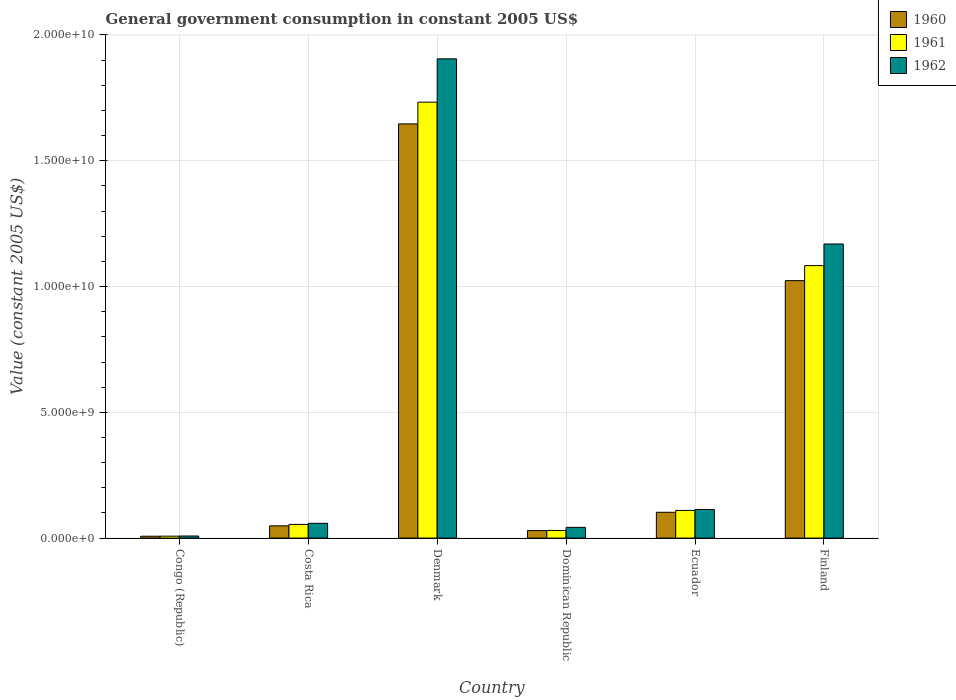How many groups of bars are there?
Your response must be concise. 6. Are the number of bars on each tick of the X-axis equal?
Offer a very short reply. Yes. How many bars are there on the 3rd tick from the right?
Make the answer very short. 3. What is the label of the 2nd group of bars from the left?
Your answer should be very brief. Costa Rica. In how many cases, is the number of bars for a given country not equal to the number of legend labels?
Make the answer very short. 0. What is the government conusmption in 1961 in Finland?
Provide a succinct answer. 1.08e+1. Across all countries, what is the maximum government conusmption in 1962?
Keep it short and to the point. 1.91e+1. Across all countries, what is the minimum government conusmption in 1962?
Your answer should be compact. 8.33e+07. In which country was the government conusmption in 1962 maximum?
Provide a short and direct response. Denmark. In which country was the government conusmption in 1961 minimum?
Provide a short and direct response. Congo (Republic). What is the total government conusmption in 1962 in the graph?
Offer a very short reply. 3.30e+1. What is the difference between the government conusmption in 1962 in Costa Rica and that in Finland?
Your answer should be compact. -1.11e+1. What is the difference between the government conusmption in 1960 in Ecuador and the government conusmption in 1961 in Dominican Republic?
Make the answer very short. 7.22e+08. What is the average government conusmption in 1960 per country?
Your answer should be compact. 4.76e+09. What is the difference between the government conusmption of/in 1962 and government conusmption of/in 1961 in Costa Rica?
Your response must be concise. 4.32e+07. What is the ratio of the government conusmption in 1962 in Congo (Republic) to that in Costa Rica?
Your response must be concise. 0.14. Is the government conusmption in 1961 in Costa Rica less than that in Dominican Republic?
Your response must be concise. No. Is the difference between the government conusmption in 1962 in Ecuador and Finland greater than the difference between the government conusmption in 1961 in Ecuador and Finland?
Keep it short and to the point. No. What is the difference between the highest and the second highest government conusmption in 1962?
Offer a very short reply. 1.06e+1. What is the difference between the highest and the lowest government conusmption in 1961?
Ensure brevity in your answer.  1.73e+1. In how many countries, is the government conusmption in 1961 greater than the average government conusmption in 1961 taken over all countries?
Your answer should be compact. 2. What does the 2nd bar from the left in Denmark represents?
Your answer should be very brief. 1961. What is the difference between two consecutive major ticks on the Y-axis?
Give a very brief answer. 5.00e+09. Are the values on the major ticks of Y-axis written in scientific E-notation?
Offer a very short reply. Yes. Does the graph contain grids?
Provide a succinct answer. Yes. Where does the legend appear in the graph?
Your answer should be compact. Top right. How are the legend labels stacked?
Provide a short and direct response. Vertical. What is the title of the graph?
Keep it short and to the point. General government consumption in constant 2005 US$. Does "1973" appear as one of the legend labels in the graph?
Your answer should be very brief. No. What is the label or title of the X-axis?
Your answer should be very brief. Country. What is the label or title of the Y-axis?
Your response must be concise. Value (constant 2005 US$). What is the Value (constant 2005 US$) in 1960 in Congo (Republic)?
Offer a terse response. 7.44e+07. What is the Value (constant 2005 US$) of 1961 in Congo (Republic)?
Your answer should be compact. 7.67e+07. What is the Value (constant 2005 US$) of 1962 in Congo (Republic)?
Offer a terse response. 8.33e+07. What is the Value (constant 2005 US$) in 1960 in Costa Rica?
Keep it short and to the point. 4.87e+08. What is the Value (constant 2005 US$) of 1961 in Costa Rica?
Provide a short and direct response. 5.45e+08. What is the Value (constant 2005 US$) of 1962 in Costa Rica?
Ensure brevity in your answer.  5.88e+08. What is the Value (constant 2005 US$) of 1960 in Denmark?
Offer a very short reply. 1.65e+1. What is the Value (constant 2005 US$) of 1961 in Denmark?
Your response must be concise. 1.73e+1. What is the Value (constant 2005 US$) in 1962 in Denmark?
Make the answer very short. 1.91e+1. What is the Value (constant 2005 US$) of 1960 in Dominican Republic?
Make the answer very short. 2.99e+08. What is the Value (constant 2005 US$) in 1961 in Dominican Republic?
Your answer should be compact. 3.03e+08. What is the Value (constant 2005 US$) of 1962 in Dominican Republic?
Your answer should be very brief. 4.27e+08. What is the Value (constant 2005 US$) in 1960 in Ecuador?
Ensure brevity in your answer.  1.03e+09. What is the Value (constant 2005 US$) of 1961 in Ecuador?
Provide a succinct answer. 1.10e+09. What is the Value (constant 2005 US$) of 1962 in Ecuador?
Offer a very short reply. 1.14e+09. What is the Value (constant 2005 US$) in 1960 in Finland?
Your answer should be compact. 1.02e+1. What is the Value (constant 2005 US$) of 1961 in Finland?
Offer a terse response. 1.08e+1. What is the Value (constant 2005 US$) in 1962 in Finland?
Keep it short and to the point. 1.17e+1. Across all countries, what is the maximum Value (constant 2005 US$) in 1960?
Make the answer very short. 1.65e+1. Across all countries, what is the maximum Value (constant 2005 US$) in 1961?
Make the answer very short. 1.73e+1. Across all countries, what is the maximum Value (constant 2005 US$) of 1962?
Offer a very short reply. 1.91e+1. Across all countries, what is the minimum Value (constant 2005 US$) in 1960?
Your answer should be very brief. 7.44e+07. Across all countries, what is the minimum Value (constant 2005 US$) in 1961?
Ensure brevity in your answer.  7.67e+07. Across all countries, what is the minimum Value (constant 2005 US$) in 1962?
Provide a short and direct response. 8.33e+07. What is the total Value (constant 2005 US$) in 1960 in the graph?
Provide a succinct answer. 2.86e+1. What is the total Value (constant 2005 US$) in 1961 in the graph?
Your answer should be compact. 3.02e+1. What is the total Value (constant 2005 US$) of 1962 in the graph?
Offer a terse response. 3.30e+1. What is the difference between the Value (constant 2005 US$) of 1960 in Congo (Republic) and that in Costa Rica?
Ensure brevity in your answer.  -4.12e+08. What is the difference between the Value (constant 2005 US$) in 1961 in Congo (Republic) and that in Costa Rica?
Provide a succinct answer. -4.68e+08. What is the difference between the Value (constant 2005 US$) of 1962 in Congo (Republic) and that in Costa Rica?
Your answer should be compact. -5.05e+08. What is the difference between the Value (constant 2005 US$) of 1960 in Congo (Republic) and that in Denmark?
Ensure brevity in your answer.  -1.64e+1. What is the difference between the Value (constant 2005 US$) of 1961 in Congo (Republic) and that in Denmark?
Make the answer very short. -1.73e+1. What is the difference between the Value (constant 2005 US$) in 1962 in Congo (Republic) and that in Denmark?
Keep it short and to the point. -1.90e+1. What is the difference between the Value (constant 2005 US$) in 1960 in Congo (Republic) and that in Dominican Republic?
Offer a very short reply. -2.24e+08. What is the difference between the Value (constant 2005 US$) of 1961 in Congo (Republic) and that in Dominican Republic?
Your answer should be compact. -2.27e+08. What is the difference between the Value (constant 2005 US$) of 1962 in Congo (Republic) and that in Dominican Republic?
Your response must be concise. -3.43e+08. What is the difference between the Value (constant 2005 US$) in 1960 in Congo (Republic) and that in Ecuador?
Ensure brevity in your answer.  -9.51e+08. What is the difference between the Value (constant 2005 US$) in 1961 in Congo (Republic) and that in Ecuador?
Make the answer very short. -1.02e+09. What is the difference between the Value (constant 2005 US$) in 1962 in Congo (Republic) and that in Ecuador?
Make the answer very short. -1.05e+09. What is the difference between the Value (constant 2005 US$) in 1960 in Congo (Republic) and that in Finland?
Give a very brief answer. -1.02e+1. What is the difference between the Value (constant 2005 US$) of 1961 in Congo (Republic) and that in Finland?
Give a very brief answer. -1.08e+1. What is the difference between the Value (constant 2005 US$) in 1962 in Congo (Republic) and that in Finland?
Provide a succinct answer. -1.16e+1. What is the difference between the Value (constant 2005 US$) of 1960 in Costa Rica and that in Denmark?
Make the answer very short. -1.60e+1. What is the difference between the Value (constant 2005 US$) of 1961 in Costa Rica and that in Denmark?
Your response must be concise. -1.68e+1. What is the difference between the Value (constant 2005 US$) in 1962 in Costa Rica and that in Denmark?
Offer a terse response. -1.85e+1. What is the difference between the Value (constant 2005 US$) in 1960 in Costa Rica and that in Dominican Republic?
Ensure brevity in your answer.  1.88e+08. What is the difference between the Value (constant 2005 US$) of 1961 in Costa Rica and that in Dominican Republic?
Your answer should be compact. 2.41e+08. What is the difference between the Value (constant 2005 US$) in 1962 in Costa Rica and that in Dominican Republic?
Offer a very short reply. 1.61e+08. What is the difference between the Value (constant 2005 US$) of 1960 in Costa Rica and that in Ecuador?
Ensure brevity in your answer.  -5.39e+08. What is the difference between the Value (constant 2005 US$) in 1961 in Costa Rica and that in Ecuador?
Offer a very short reply. -5.55e+08. What is the difference between the Value (constant 2005 US$) of 1962 in Costa Rica and that in Ecuador?
Your answer should be very brief. -5.50e+08. What is the difference between the Value (constant 2005 US$) in 1960 in Costa Rica and that in Finland?
Your answer should be compact. -9.75e+09. What is the difference between the Value (constant 2005 US$) of 1961 in Costa Rica and that in Finland?
Make the answer very short. -1.03e+1. What is the difference between the Value (constant 2005 US$) in 1962 in Costa Rica and that in Finland?
Your response must be concise. -1.11e+1. What is the difference between the Value (constant 2005 US$) of 1960 in Denmark and that in Dominican Republic?
Offer a terse response. 1.62e+1. What is the difference between the Value (constant 2005 US$) in 1961 in Denmark and that in Dominican Republic?
Offer a very short reply. 1.70e+1. What is the difference between the Value (constant 2005 US$) of 1962 in Denmark and that in Dominican Republic?
Make the answer very short. 1.86e+1. What is the difference between the Value (constant 2005 US$) of 1960 in Denmark and that in Ecuador?
Offer a very short reply. 1.54e+1. What is the difference between the Value (constant 2005 US$) of 1961 in Denmark and that in Ecuador?
Keep it short and to the point. 1.62e+1. What is the difference between the Value (constant 2005 US$) in 1962 in Denmark and that in Ecuador?
Keep it short and to the point. 1.79e+1. What is the difference between the Value (constant 2005 US$) of 1960 in Denmark and that in Finland?
Offer a very short reply. 6.23e+09. What is the difference between the Value (constant 2005 US$) in 1961 in Denmark and that in Finland?
Ensure brevity in your answer.  6.50e+09. What is the difference between the Value (constant 2005 US$) in 1962 in Denmark and that in Finland?
Your response must be concise. 7.36e+09. What is the difference between the Value (constant 2005 US$) in 1960 in Dominican Republic and that in Ecuador?
Provide a succinct answer. -7.27e+08. What is the difference between the Value (constant 2005 US$) in 1961 in Dominican Republic and that in Ecuador?
Offer a terse response. -7.96e+08. What is the difference between the Value (constant 2005 US$) of 1962 in Dominican Republic and that in Ecuador?
Offer a very short reply. -7.11e+08. What is the difference between the Value (constant 2005 US$) in 1960 in Dominican Republic and that in Finland?
Make the answer very short. -9.94e+09. What is the difference between the Value (constant 2005 US$) in 1961 in Dominican Republic and that in Finland?
Your answer should be compact. -1.05e+1. What is the difference between the Value (constant 2005 US$) of 1962 in Dominican Republic and that in Finland?
Your response must be concise. -1.13e+1. What is the difference between the Value (constant 2005 US$) of 1960 in Ecuador and that in Finland?
Give a very brief answer. -9.21e+09. What is the difference between the Value (constant 2005 US$) of 1961 in Ecuador and that in Finland?
Offer a very short reply. -9.73e+09. What is the difference between the Value (constant 2005 US$) in 1962 in Ecuador and that in Finland?
Provide a short and direct response. -1.06e+1. What is the difference between the Value (constant 2005 US$) of 1960 in Congo (Republic) and the Value (constant 2005 US$) of 1961 in Costa Rica?
Offer a terse response. -4.70e+08. What is the difference between the Value (constant 2005 US$) of 1960 in Congo (Republic) and the Value (constant 2005 US$) of 1962 in Costa Rica?
Your response must be concise. -5.13e+08. What is the difference between the Value (constant 2005 US$) in 1961 in Congo (Republic) and the Value (constant 2005 US$) in 1962 in Costa Rica?
Give a very brief answer. -5.11e+08. What is the difference between the Value (constant 2005 US$) of 1960 in Congo (Republic) and the Value (constant 2005 US$) of 1961 in Denmark?
Offer a very short reply. -1.73e+1. What is the difference between the Value (constant 2005 US$) of 1960 in Congo (Republic) and the Value (constant 2005 US$) of 1962 in Denmark?
Offer a terse response. -1.90e+1. What is the difference between the Value (constant 2005 US$) of 1961 in Congo (Republic) and the Value (constant 2005 US$) of 1962 in Denmark?
Your response must be concise. -1.90e+1. What is the difference between the Value (constant 2005 US$) in 1960 in Congo (Republic) and the Value (constant 2005 US$) in 1961 in Dominican Republic?
Keep it short and to the point. -2.29e+08. What is the difference between the Value (constant 2005 US$) of 1960 in Congo (Republic) and the Value (constant 2005 US$) of 1962 in Dominican Republic?
Your response must be concise. -3.52e+08. What is the difference between the Value (constant 2005 US$) of 1961 in Congo (Republic) and the Value (constant 2005 US$) of 1962 in Dominican Republic?
Offer a terse response. -3.50e+08. What is the difference between the Value (constant 2005 US$) in 1960 in Congo (Republic) and the Value (constant 2005 US$) in 1961 in Ecuador?
Provide a short and direct response. -1.02e+09. What is the difference between the Value (constant 2005 US$) in 1960 in Congo (Republic) and the Value (constant 2005 US$) in 1962 in Ecuador?
Your response must be concise. -1.06e+09. What is the difference between the Value (constant 2005 US$) in 1961 in Congo (Republic) and the Value (constant 2005 US$) in 1962 in Ecuador?
Your response must be concise. -1.06e+09. What is the difference between the Value (constant 2005 US$) of 1960 in Congo (Republic) and the Value (constant 2005 US$) of 1961 in Finland?
Your answer should be compact. -1.08e+1. What is the difference between the Value (constant 2005 US$) of 1960 in Congo (Republic) and the Value (constant 2005 US$) of 1962 in Finland?
Your answer should be compact. -1.16e+1. What is the difference between the Value (constant 2005 US$) of 1961 in Congo (Republic) and the Value (constant 2005 US$) of 1962 in Finland?
Provide a succinct answer. -1.16e+1. What is the difference between the Value (constant 2005 US$) in 1960 in Costa Rica and the Value (constant 2005 US$) in 1961 in Denmark?
Ensure brevity in your answer.  -1.68e+1. What is the difference between the Value (constant 2005 US$) of 1960 in Costa Rica and the Value (constant 2005 US$) of 1962 in Denmark?
Give a very brief answer. -1.86e+1. What is the difference between the Value (constant 2005 US$) of 1961 in Costa Rica and the Value (constant 2005 US$) of 1962 in Denmark?
Provide a succinct answer. -1.85e+1. What is the difference between the Value (constant 2005 US$) of 1960 in Costa Rica and the Value (constant 2005 US$) of 1961 in Dominican Republic?
Your answer should be very brief. 1.83e+08. What is the difference between the Value (constant 2005 US$) in 1960 in Costa Rica and the Value (constant 2005 US$) in 1962 in Dominican Republic?
Your answer should be compact. 6.01e+07. What is the difference between the Value (constant 2005 US$) of 1961 in Costa Rica and the Value (constant 2005 US$) of 1962 in Dominican Republic?
Your answer should be very brief. 1.18e+08. What is the difference between the Value (constant 2005 US$) of 1960 in Costa Rica and the Value (constant 2005 US$) of 1961 in Ecuador?
Provide a short and direct response. -6.13e+08. What is the difference between the Value (constant 2005 US$) of 1960 in Costa Rica and the Value (constant 2005 US$) of 1962 in Ecuador?
Your answer should be compact. -6.51e+08. What is the difference between the Value (constant 2005 US$) in 1961 in Costa Rica and the Value (constant 2005 US$) in 1962 in Ecuador?
Your response must be concise. -5.93e+08. What is the difference between the Value (constant 2005 US$) of 1960 in Costa Rica and the Value (constant 2005 US$) of 1961 in Finland?
Provide a succinct answer. -1.03e+1. What is the difference between the Value (constant 2005 US$) of 1960 in Costa Rica and the Value (constant 2005 US$) of 1962 in Finland?
Provide a succinct answer. -1.12e+1. What is the difference between the Value (constant 2005 US$) of 1961 in Costa Rica and the Value (constant 2005 US$) of 1962 in Finland?
Provide a short and direct response. -1.11e+1. What is the difference between the Value (constant 2005 US$) in 1960 in Denmark and the Value (constant 2005 US$) in 1961 in Dominican Republic?
Provide a short and direct response. 1.62e+1. What is the difference between the Value (constant 2005 US$) in 1960 in Denmark and the Value (constant 2005 US$) in 1962 in Dominican Republic?
Ensure brevity in your answer.  1.60e+1. What is the difference between the Value (constant 2005 US$) of 1961 in Denmark and the Value (constant 2005 US$) of 1962 in Dominican Republic?
Your answer should be very brief. 1.69e+1. What is the difference between the Value (constant 2005 US$) in 1960 in Denmark and the Value (constant 2005 US$) in 1961 in Ecuador?
Your answer should be very brief. 1.54e+1. What is the difference between the Value (constant 2005 US$) of 1960 in Denmark and the Value (constant 2005 US$) of 1962 in Ecuador?
Your answer should be very brief. 1.53e+1. What is the difference between the Value (constant 2005 US$) in 1961 in Denmark and the Value (constant 2005 US$) in 1962 in Ecuador?
Give a very brief answer. 1.62e+1. What is the difference between the Value (constant 2005 US$) in 1960 in Denmark and the Value (constant 2005 US$) in 1961 in Finland?
Offer a terse response. 5.63e+09. What is the difference between the Value (constant 2005 US$) of 1960 in Denmark and the Value (constant 2005 US$) of 1962 in Finland?
Provide a succinct answer. 4.77e+09. What is the difference between the Value (constant 2005 US$) of 1961 in Denmark and the Value (constant 2005 US$) of 1962 in Finland?
Your answer should be compact. 5.64e+09. What is the difference between the Value (constant 2005 US$) of 1960 in Dominican Republic and the Value (constant 2005 US$) of 1961 in Ecuador?
Offer a terse response. -8.01e+08. What is the difference between the Value (constant 2005 US$) in 1960 in Dominican Republic and the Value (constant 2005 US$) in 1962 in Ecuador?
Offer a terse response. -8.39e+08. What is the difference between the Value (constant 2005 US$) in 1961 in Dominican Republic and the Value (constant 2005 US$) in 1962 in Ecuador?
Make the answer very short. -8.35e+08. What is the difference between the Value (constant 2005 US$) in 1960 in Dominican Republic and the Value (constant 2005 US$) in 1961 in Finland?
Provide a succinct answer. -1.05e+1. What is the difference between the Value (constant 2005 US$) in 1960 in Dominican Republic and the Value (constant 2005 US$) in 1962 in Finland?
Offer a very short reply. -1.14e+1. What is the difference between the Value (constant 2005 US$) of 1961 in Dominican Republic and the Value (constant 2005 US$) of 1962 in Finland?
Provide a succinct answer. -1.14e+1. What is the difference between the Value (constant 2005 US$) of 1960 in Ecuador and the Value (constant 2005 US$) of 1961 in Finland?
Offer a terse response. -9.81e+09. What is the difference between the Value (constant 2005 US$) of 1960 in Ecuador and the Value (constant 2005 US$) of 1962 in Finland?
Give a very brief answer. -1.07e+1. What is the difference between the Value (constant 2005 US$) in 1961 in Ecuador and the Value (constant 2005 US$) in 1962 in Finland?
Provide a succinct answer. -1.06e+1. What is the average Value (constant 2005 US$) in 1960 per country?
Your response must be concise. 4.76e+09. What is the average Value (constant 2005 US$) in 1961 per country?
Offer a very short reply. 5.03e+09. What is the average Value (constant 2005 US$) in 1962 per country?
Offer a very short reply. 5.50e+09. What is the difference between the Value (constant 2005 US$) in 1960 and Value (constant 2005 US$) in 1961 in Congo (Republic)?
Provide a succinct answer. -2.22e+06. What is the difference between the Value (constant 2005 US$) in 1960 and Value (constant 2005 US$) in 1962 in Congo (Republic)?
Your answer should be very brief. -8.89e+06. What is the difference between the Value (constant 2005 US$) of 1961 and Value (constant 2005 US$) of 1962 in Congo (Republic)?
Ensure brevity in your answer.  -6.67e+06. What is the difference between the Value (constant 2005 US$) of 1960 and Value (constant 2005 US$) of 1961 in Costa Rica?
Your answer should be very brief. -5.79e+07. What is the difference between the Value (constant 2005 US$) in 1960 and Value (constant 2005 US$) in 1962 in Costa Rica?
Provide a succinct answer. -1.01e+08. What is the difference between the Value (constant 2005 US$) in 1961 and Value (constant 2005 US$) in 1962 in Costa Rica?
Provide a short and direct response. -4.32e+07. What is the difference between the Value (constant 2005 US$) in 1960 and Value (constant 2005 US$) in 1961 in Denmark?
Ensure brevity in your answer.  -8.65e+08. What is the difference between the Value (constant 2005 US$) of 1960 and Value (constant 2005 US$) of 1962 in Denmark?
Your answer should be compact. -2.59e+09. What is the difference between the Value (constant 2005 US$) in 1961 and Value (constant 2005 US$) in 1962 in Denmark?
Your answer should be compact. -1.72e+09. What is the difference between the Value (constant 2005 US$) of 1960 and Value (constant 2005 US$) of 1961 in Dominican Republic?
Your answer should be very brief. -4.75e+06. What is the difference between the Value (constant 2005 US$) of 1960 and Value (constant 2005 US$) of 1962 in Dominican Republic?
Offer a terse response. -1.28e+08. What is the difference between the Value (constant 2005 US$) of 1961 and Value (constant 2005 US$) of 1962 in Dominican Republic?
Provide a succinct answer. -1.23e+08. What is the difference between the Value (constant 2005 US$) of 1960 and Value (constant 2005 US$) of 1961 in Ecuador?
Your answer should be very brief. -7.35e+07. What is the difference between the Value (constant 2005 US$) of 1960 and Value (constant 2005 US$) of 1962 in Ecuador?
Offer a very short reply. -1.12e+08. What is the difference between the Value (constant 2005 US$) in 1961 and Value (constant 2005 US$) in 1962 in Ecuador?
Your answer should be very brief. -3.85e+07. What is the difference between the Value (constant 2005 US$) in 1960 and Value (constant 2005 US$) in 1961 in Finland?
Give a very brief answer. -5.98e+08. What is the difference between the Value (constant 2005 US$) of 1960 and Value (constant 2005 US$) of 1962 in Finland?
Keep it short and to the point. -1.46e+09. What is the difference between the Value (constant 2005 US$) in 1961 and Value (constant 2005 US$) in 1962 in Finland?
Provide a succinct answer. -8.59e+08. What is the ratio of the Value (constant 2005 US$) in 1960 in Congo (Republic) to that in Costa Rica?
Make the answer very short. 0.15. What is the ratio of the Value (constant 2005 US$) in 1961 in Congo (Republic) to that in Costa Rica?
Your answer should be very brief. 0.14. What is the ratio of the Value (constant 2005 US$) of 1962 in Congo (Republic) to that in Costa Rica?
Give a very brief answer. 0.14. What is the ratio of the Value (constant 2005 US$) of 1960 in Congo (Republic) to that in Denmark?
Make the answer very short. 0. What is the ratio of the Value (constant 2005 US$) of 1961 in Congo (Republic) to that in Denmark?
Your answer should be very brief. 0. What is the ratio of the Value (constant 2005 US$) in 1962 in Congo (Republic) to that in Denmark?
Your answer should be very brief. 0. What is the ratio of the Value (constant 2005 US$) in 1960 in Congo (Republic) to that in Dominican Republic?
Provide a succinct answer. 0.25. What is the ratio of the Value (constant 2005 US$) of 1961 in Congo (Republic) to that in Dominican Republic?
Give a very brief answer. 0.25. What is the ratio of the Value (constant 2005 US$) of 1962 in Congo (Republic) to that in Dominican Republic?
Make the answer very short. 0.2. What is the ratio of the Value (constant 2005 US$) of 1960 in Congo (Republic) to that in Ecuador?
Your answer should be very brief. 0.07. What is the ratio of the Value (constant 2005 US$) of 1961 in Congo (Republic) to that in Ecuador?
Offer a terse response. 0.07. What is the ratio of the Value (constant 2005 US$) in 1962 in Congo (Republic) to that in Ecuador?
Give a very brief answer. 0.07. What is the ratio of the Value (constant 2005 US$) of 1960 in Congo (Republic) to that in Finland?
Keep it short and to the point. 0.01. What is the ratio of the Value (constant 2005 US$) in 1961 in Congo (Republic) to that in Finland?
Provide a short and direct response. 0.01. What is the ratio of the Value (constant 2005 US$) of 1962 in Congo (Republic) to that in Finland?
Offer a terse response. 0.01. What is the ratio of the Value (constant 2005 US$) in 1960 in Costa Rica to that in Denmark?
Your answer should be very brief. 0.03. What is the ratio of the Value (constant 2005 US$) in 1961 in Costa Rica to that in Denmark?
Offer a terse response. 0.03. What is the ratio of the Value (constant 2005 US$) of 1962 in Costa Rica to that in Denmark?
Your response must be concise. 0.03. What is the ratio of the Value (constant 2005 US$) in 1960 in Costa Rica to that in Dominican Republic?
Provide a short and direct response. 1.63. What is the ratio of the Value (constant 2005 US$) of 1961 in Costa Rica to that in Dominican Republic?
Your answer should be compact. 1.8. What is the ratio of the Value (constant 2005 US$) of 1962 in Costa Rica to that in Dominican Republic?
Offer a very short reply. 1.38. What is the ratio of the Value (constant 2005 US$) in 1960 in Costa Rica to that in Ecuador?
Provide a succinct answer. 0.47. What is the ratio of the Value (constant 2005 US$) in 1961 in Costa Rica to that in Ecuador?
Keep it short and to the point. 0.5. What is the ratio of the Value (constant 2005 US$) in 1962 in Costa Rica to that in Ecuador?
Your answer should be compact. 0.52. What is the ratio of the Value (constant 2005 US$) in 1960 in Costa Rica to that in Finland?
Provide a short and direct response. 0.05. What is the ratio of the Value (constant 2005 US$) in 1961 in Costa Rica to that in Finland?
Ensure brevity in your answer.  0.05. What is the ratio of the Value (constant 2005 US$) in 1962 in Costa Rica to that in Finland?
Your answer should be very brief. 0.05. What is the ratio of the Value (constant 2005 US$) in 1960 in Denmark to that in Dominican Republic?
Offer a terse response. 55.14. What is the ratio of the Value (constant 2005 US$) of 1961 in Denmark to that in Dominican Republic?
Provide a succinct answer. 57.13. What is the ratio of the Value (constant 2005 US$) of 1962 in Denmark to that in Dominican Republic?
Keep it short and to the point. 44.66. What is the ratio of the Value (constant 2005 US$) of 1960 in Denmark to that in Ecuador?
Give a very brief answer. 16.05. What is the ratio of the Value (constant 2005 US$) in 1961 in Denmark to that in Ecuador?
Offer a terse response. 15.76. What is the ratio of the Value (constant 2005 US$) of 1962 in Denmark to that in Ecuador?
Give a very brief answer. 16.74. What is the ratio of the Value (constant 2005 US$) of 1960 in Denmark to that in Finland?
Make the answer very short. 1.61. What is the ratio of the Value (constant 2005 US$) of 1961 in Denmark to that in Finland?
Your answer should be compact. 1.6. What is the ratio of the Value (constant 2005 US$) of 1962 in Denmark to that in Finland?
Provide a succinct answer. 1.63. What is the ratio of the Value (constant 2005 US$) in 1960 in Dominican Republic to that in Ecuador?
Your answer should be compact. 0.29. What is the ratio of the Value (constant 2005 US$) of 1961 in Dominican Republic to that in Ecuador?
Your response must be concise. 0.28. What is the ratio of the Value (constant 2005 US$) in 1962 in Dominican Republic to that in Ecuador?
Keep it short and to the point. 0.37. What is the ratio of the Value (constant 2005 US$) in 1960 in Dominican Republic to that in Finland?
Provide a succinct answer. 0.03. What is the ratio of the Value (constant 2005 US$) in 1961 in Dominican Republic to that in Finland?
Your response must be concise. 0.03. What is the ratio of the Value (constant 2005 US$) in 1962 in Dominican Republic to that in Finland?
Keep it short and to the point. 0.04. What is the ratio of the Value (constant 2005 US$) in 1960 in Ecuador to that in Finland?
Provide a succinct answer. 0.1. What is the ratio of the Value (constant 2005 US$) in 1961 in Ecuador to that in Finland?
Your answer should be very brief. 0.1. What is the ratio of the Value (constant 2005 US$) of 1962 in Ecuador to that in Finland?
Make the answer very short. 0.1. What is the difference between the highest and the second highest Value (constant 2005 US$) of 1960?
Provide a short and direct response. 6.23e+09. What is the difference between the highest and the second highest Value (constant 2005 US$) in 1961?
Offer a terse response. 6.50e+09. What is the difference between the highest and the second highest Value (constant 2005 US$) in 1962?
Provide a short and direct response. 7.36e+09. What is the difference between the highest and the lowest Value (constant 2005 US$) of 1960?
Your answer should be compact. 1.64e+1. What is the difference between the highest and the lowest Value (constant 2005 US$) of 1961?
Offer a very short reply. 1.73e+1. What is the difference between the highest and the lowest Value (constant 2005 US$) of 1962?
Your response must be concise. 1.90e+1. 